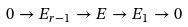Convert formula to latex. <formula><loc_0><loc_0><loc_500><loc_500>0 \to E _ { r - 1 } \to E \to E _ { 1 } \to 0</formula> 